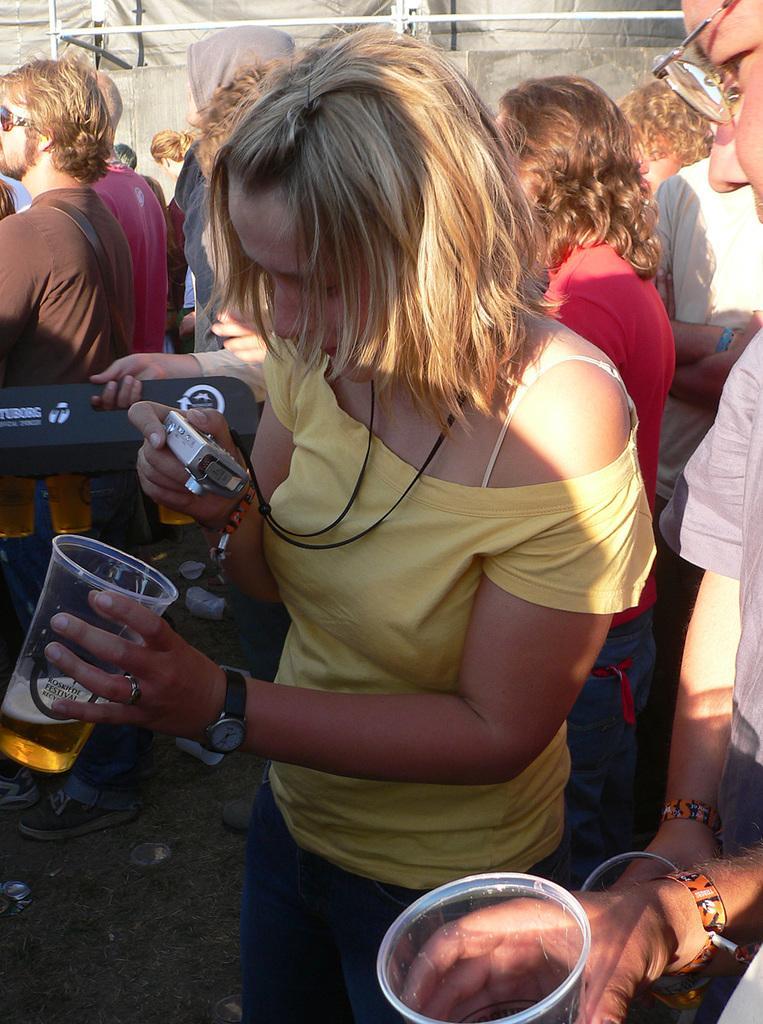How would you summarize this image in a sentence or two? In this picture we can see few persons standing. Here one women in yellow shirt taking a snap of the glass in which there is a liquid through camera. 